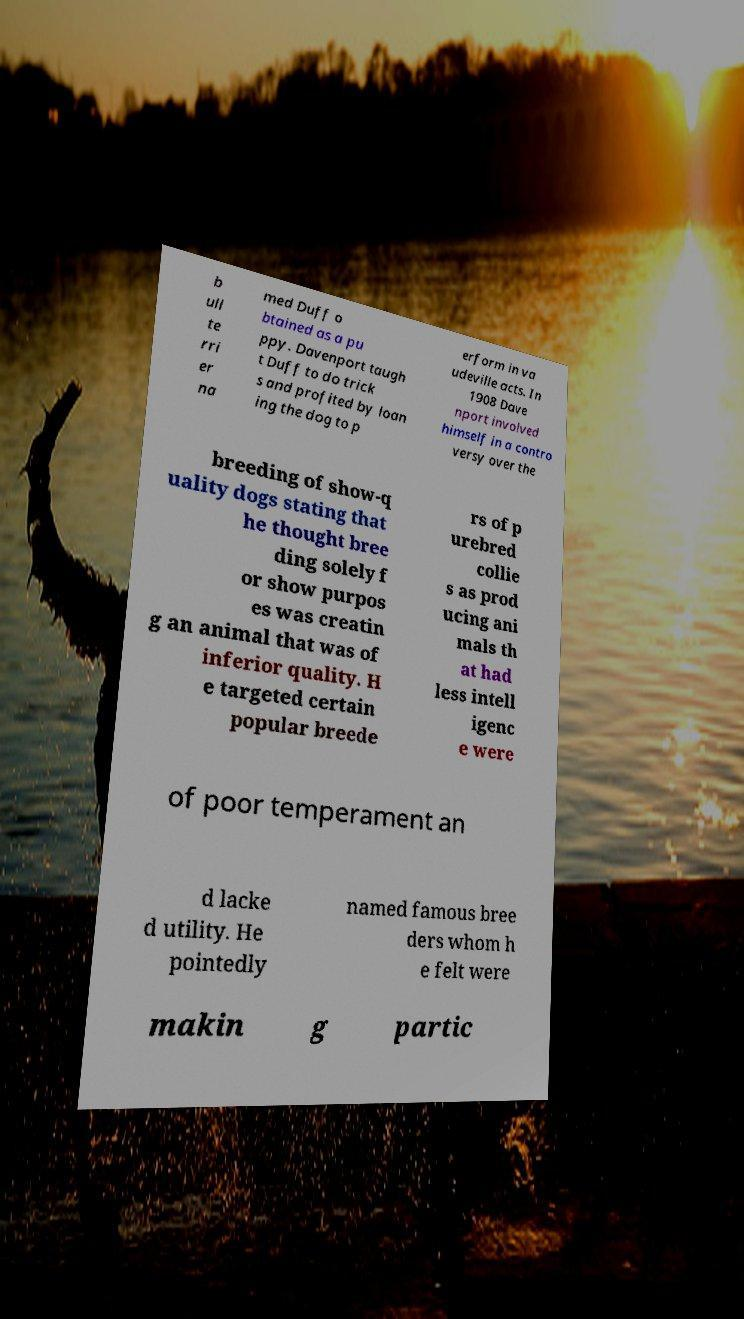Could you extract and type out the text from this image? b ull te rri er na med Duff o btained as a pu ppy. Davenport taugh t Duff to do trick s and profited by loan ing the dog to p erform in va udeville acts. In 1908 Dave nport involved himself in a contro versy over the breeding of show-q uality dogs stating that he thought bree ding solely f or show purpos es was creatin g an animal that was of inferior quality. H e targeted certain popular breede rs of p urebred collie s as prod ucing ani mals th at had less intell igenc e were of poor temperament an d lacke d utility. He pointedly named famous bree ders whom h e felt were makin g partic 